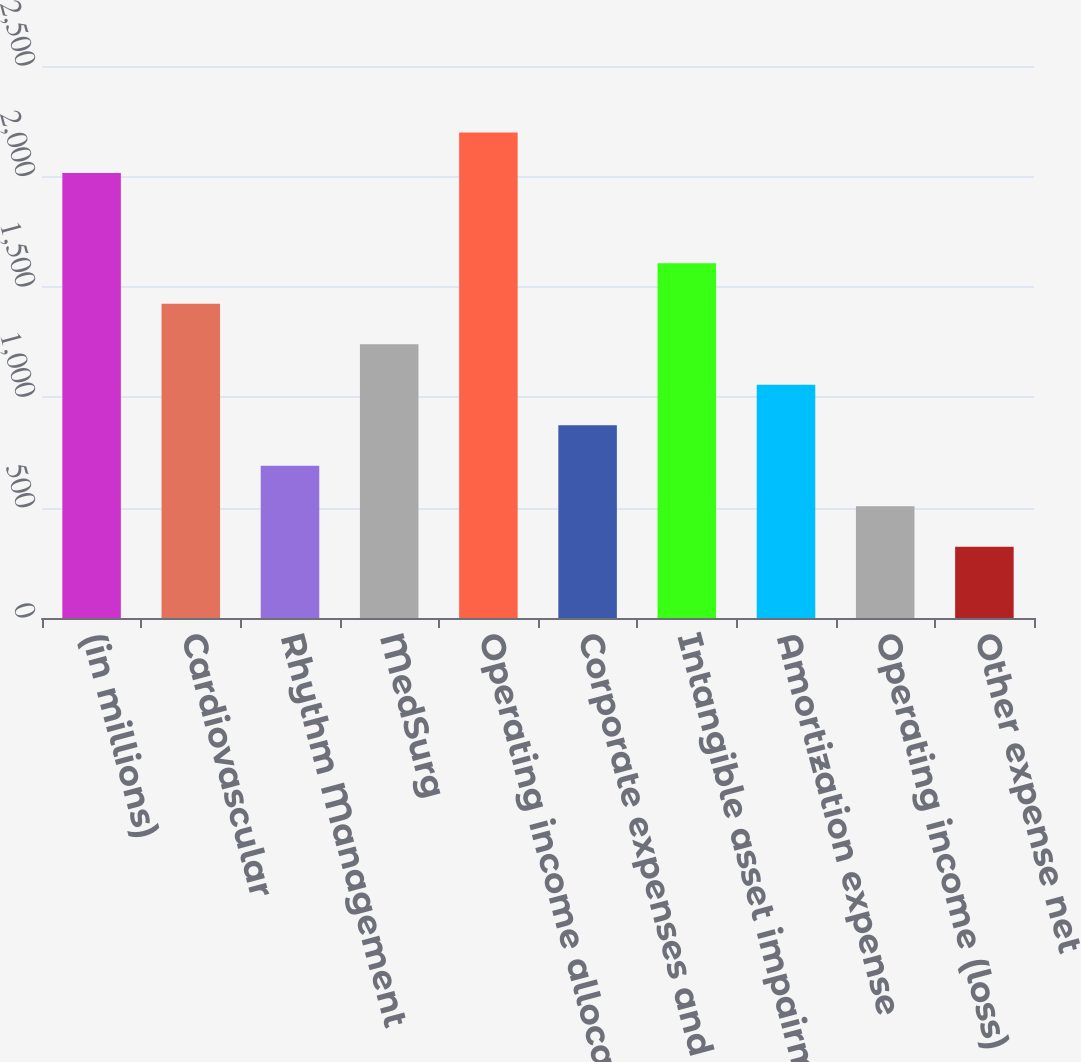Convert chart to OTSL. <chart><loc_0><loc_0><loc_500><loc_500><bar_chart><fcel>(in millions)<fcel>Cardiovascular<fcel>Rhythm Management<fcel>MedSurg<fcel>Operating income allocated to<fcel>Corporate expenses and<fcel>Intangible asset impairment<fcel>Amortization expense<fcel>Operating income (loss)<fcel>Other expense net<nl><fcel>2015<fcel>1422.8<fcel>689.6<fcel>1239.5<fcel>2198.3<fcel>872.9<fcel>1606.1<fcel>1056.2<fcel>506.3<fcel>323<nl></chart> 